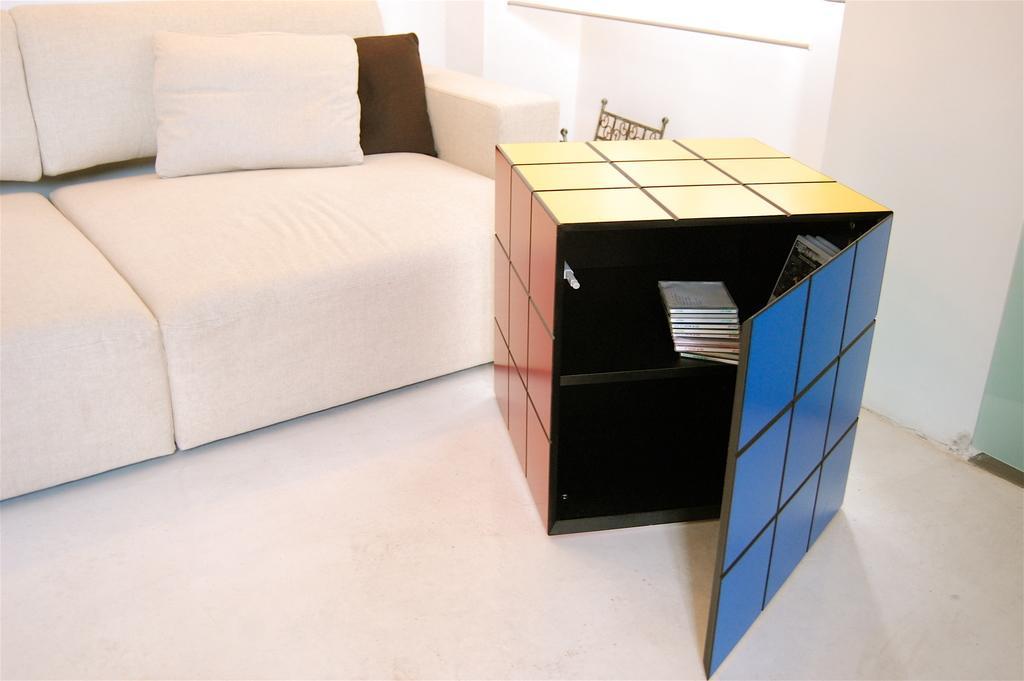Describe this image in one or two sentences. This picture we see a sofa with two pillows and a cupboard 